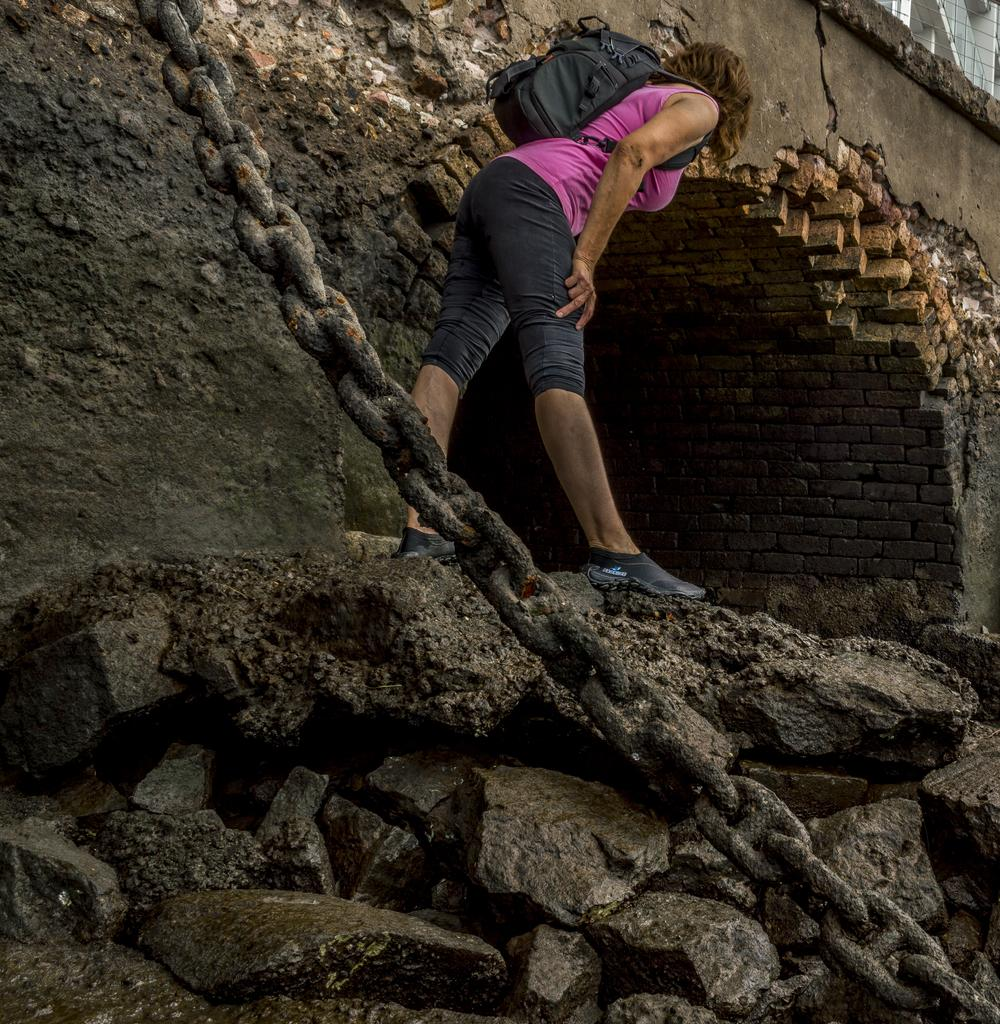What is the main subject in the image? There is a woman standing in the image. What can be seen in the background of the image? There is a wall in the background of the image. What is located in the foreground of the image? There is a chain in the foreground of the image. What is present at the bottom of the image? There are stones and mud at the bottom of the image. What type of food is being served at the airport in the image? There is no airport or food present in the image; it features a woman standing with a wall, chain, stones, and mud in the background and foreground. 